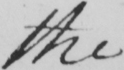Can you tell me what this handwritten text says? the 